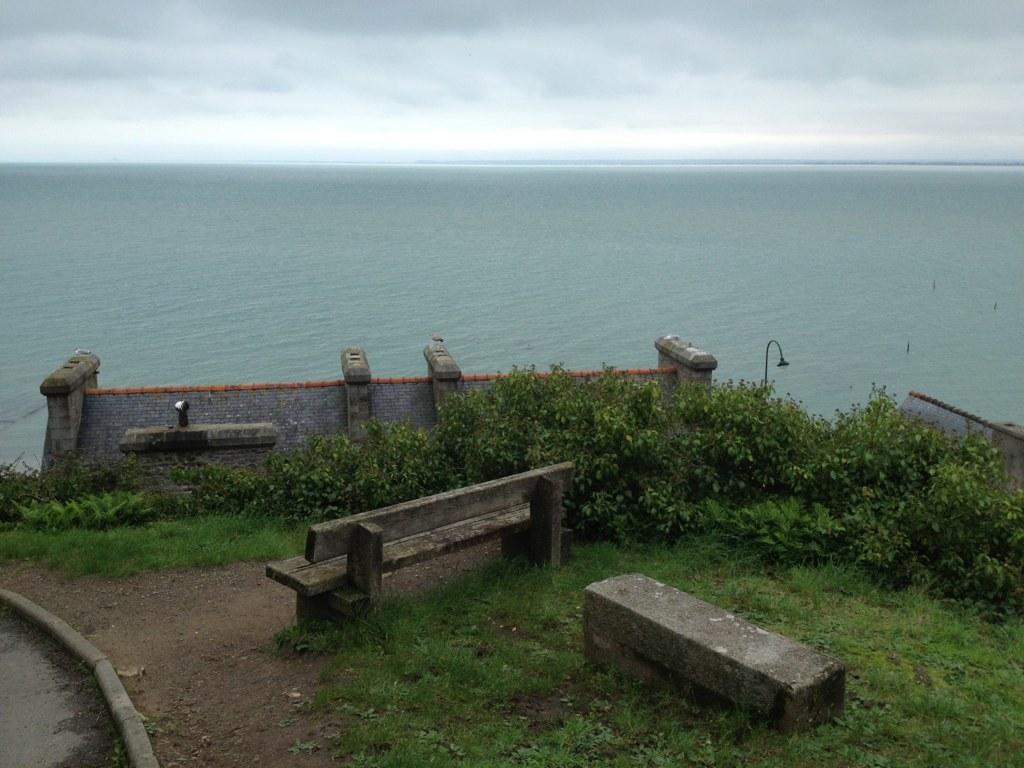Can you describe this image briefly? Here we can see bench, grass, plants, wall and light pole. Background we can see water and sky. Sky is cloudy. 